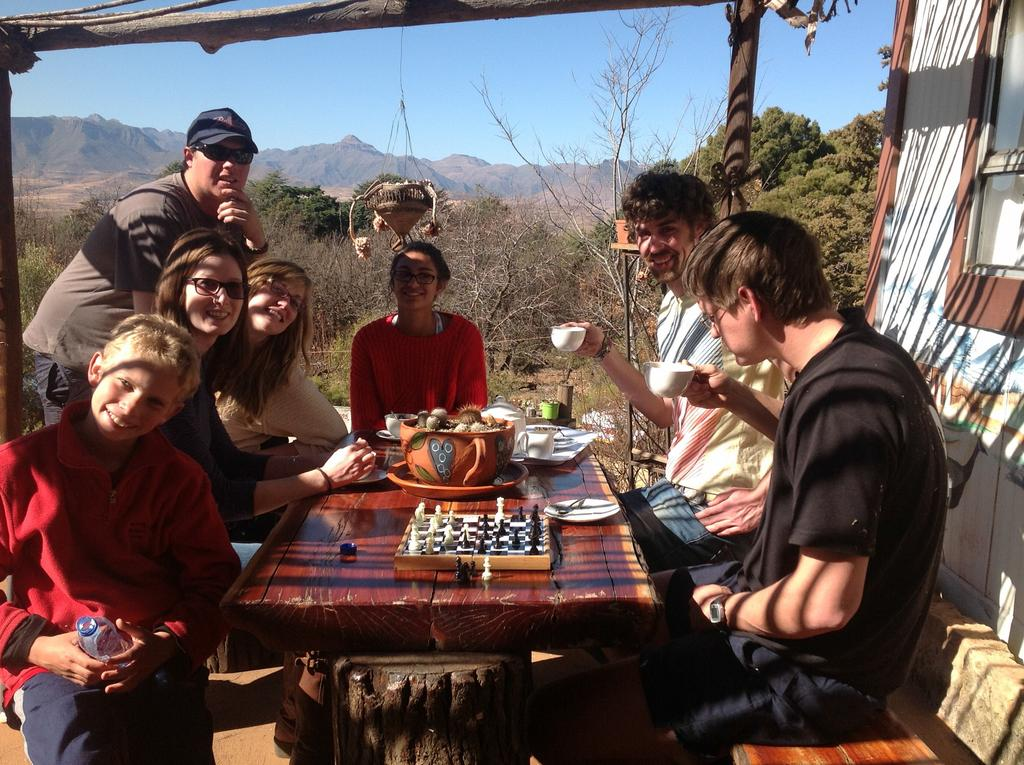How many people are in the image? There is a group of people in the image. What are the people doing in the image? The people are sitting on a bench. Where is the bench located in relation to the table? The bench is in front of a table. What can be found on the table? There are objects on the table. What type of cat is sitting on the wall in the image? There is no cat or wall present in the image. How many cakes are on the table in the image? The provided facts do not specify the type of objects on the table, so we cannot determine if there are any cakes. 